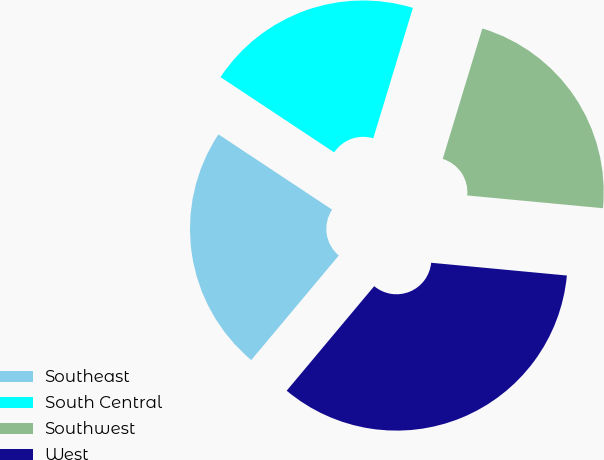<chart> <loc_0><loc_0><loc_500><loc_500><pie_chart><fcel>Southeast<fcel>South Central<fcel>Southwest<fcel>West<nl><fcel>23.22%<fcel>20.38%<fcel>21.8%<fcel>34.6%<nl></chart> 